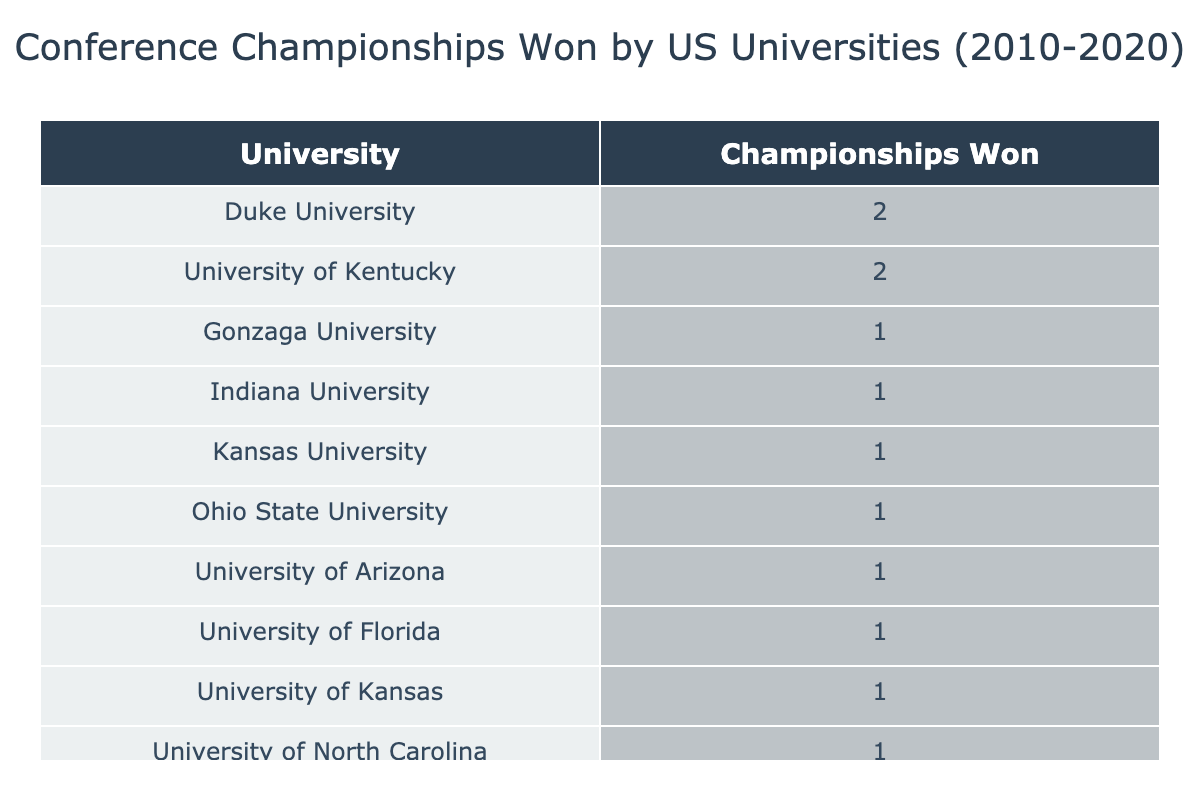What university won the most conference championships? Looking at the table, Duke University and University of Kentucky each have 2 championships, while all other universities have only 1. Since no university has more than 2, both Duke University and University of Kentucky are tied for the most.
Answer: Duke University and University of Kentucky How many championships did the University of Kansas win between 2010 and 2020? The table shows that the University of Kansas won 1 championship in 2010 and again in 2020. Adding these gives a total of 2 championships.
Answer: 2 Did the University of Florida win any championships during this period? The table indicates that the University of Florida won 1 championship in 2020. Therefore, the statement is true.
Answer: Yes Which conference had the highest number of championships won? By examining the table, we can count that the ACC has 5 championships (Duke, North Carolina, Virginia), the B1G has 3 championships (Ohio State, Indiana, Wisconsin), the SEC has 3 (Kentucky, Florida), and the others have fewer. So, ACC is the conference with the highest number.
Answer: ACC What is the total number of championships won by universities in the B1G conference? The B1G conference had championships from three universities: Ohio State (1), Indiana (1), and Wisconsin (1). Adding these totals gives us 1 + 1 + 1 = 3 championships in total.
Answer: 3 How many different universities won championships in 2020? According to the table, two universities won championships in 2020: Kansas and Florida. This means the total number of different universities that won in 2020 is 2.
Answer: 2 Which university won championships in consecutive years? The table only shows Duke University winning in the years 2010 and 2019, and Kentucky winning in 2012. No other universities appear to have won in back-to-back years as there are no consecutive years for any of the outputs.
Answer: No What is the difference in the number of championships between the top university and the one with the least? The top universities (Duke and Kentucky) have 2 championships each, while all other universities have just 1 championship. The difference is calculated as 2 - 1 = 1.
Answer: 1 